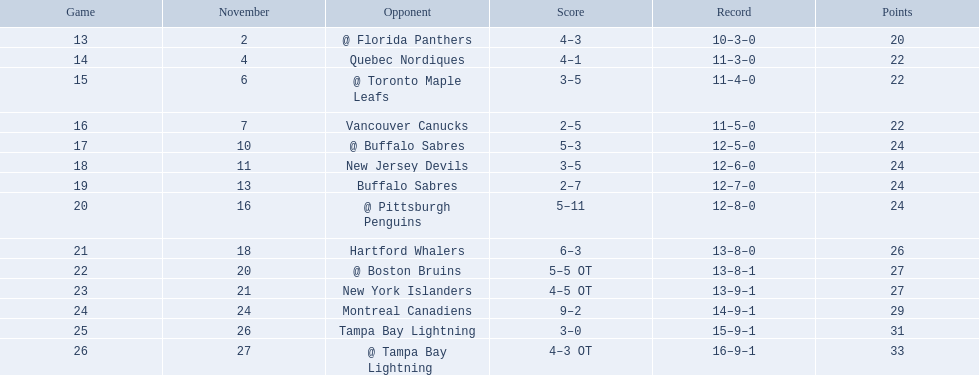What are the names of all the teams? @ Florida Panthers, Quebec Nordiques, @ Toronto Maple Leafs, Vancouver Canucks, @ Buffalo Sabres, New Jersey Devils, Buffalo Sabres, @ Pittsburgh Penguins, Hartford Whalers, @ Boston Bruins, New York Islanders, Montreal Canadiens, Tampa Bay Lightning. Which games were completed in overtime? 22, 23, 26. In the twenty-third game, who were the opponents? New York Islanders. 